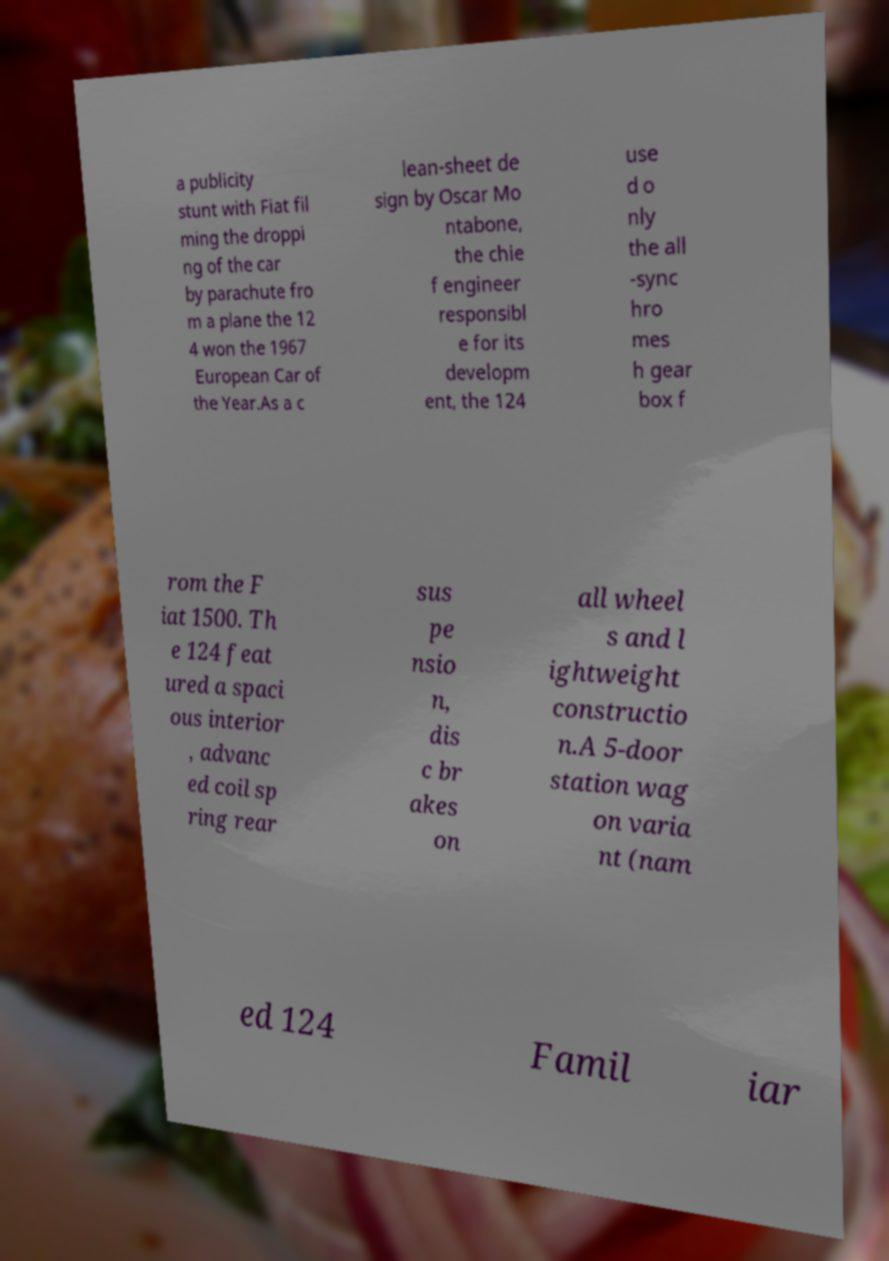Please read and relay the text visible in this image. What does it say? a publicity stunt with Fiat fil ming the droppi ng of the car by parachute fro m a plane the 12 4 won the 1967 European Car of the Year.As a c lean-sheet de sign by Oscar Mo ntabone, the chie f engineer responsibl e for its developm ent, the 124 use d o nly the all -sync hro mes h gear box f rom the F iat 1500. Th e 124 feat ured a spaci ous interior , advanc ed coil sp ring rear sus pe nsio n, dis c br akes on all wheel s and l ightweight constructio n.A 5-door station wag on varia nt (nam ed 124 Famil iar 